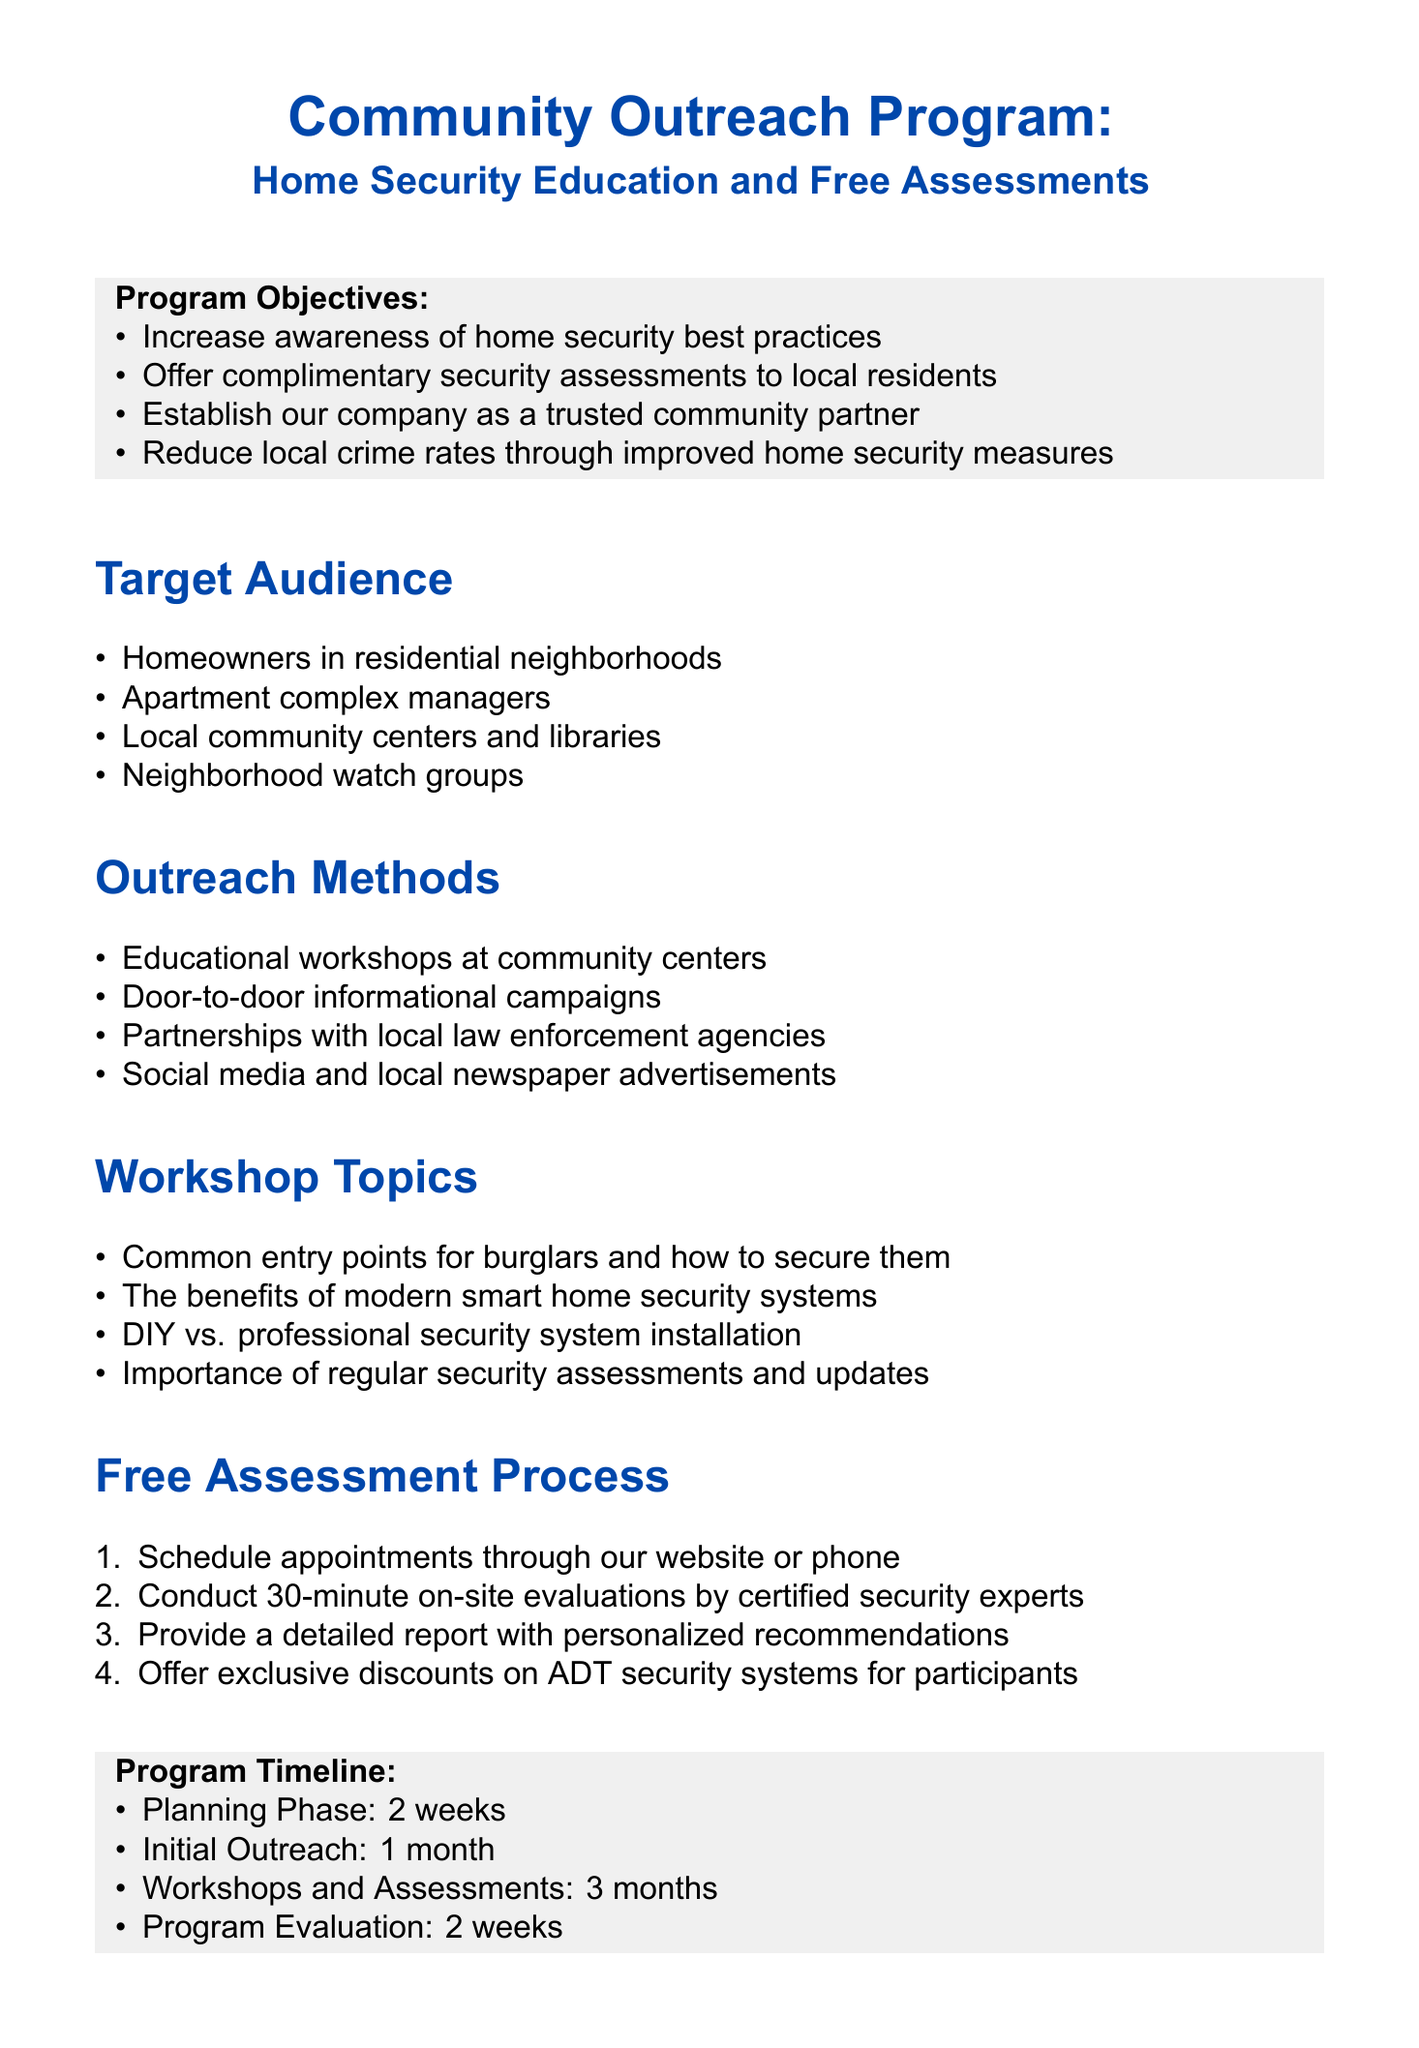What is the title of the memo? The title of the memo is stated at the top of the document.
Answer: Community Outreach Program: Home Security Education and Free Assessments What is the main audience for the program? The target audience is listed in a specific section of the document.
Answer: Homeowners in residential neighborhoods How long is the planning phase? The duration of each program phase is mentioned in the timeline section.
Answer: 2 weeks What team member is the Program Coordinator? The team members and their roles are specified in the document.
Answer: Sarah Johnson Which method involves community centers? The outreach methods section includes various strategies for community engagement.
Answer: Educational workshops at community centers How many months is the workshop and assessment phase? The timeline indicates how long each phase will take.
Answer: 3 months What is one of the partnership opportunities mentioned? Specific collaboration options are outlined in the document.
Answer: Collaborate with Ring for discounted video doorbells What is one of the success metrics for the program? The success metrics are listed to measure the program's effectiveness.
Answer: Number of workshop attendees What will be conducted during the free assessment process? The assessment process details are outlined in the relevant section.
Answer: 30-minute on-site evaluations by certified security experts 